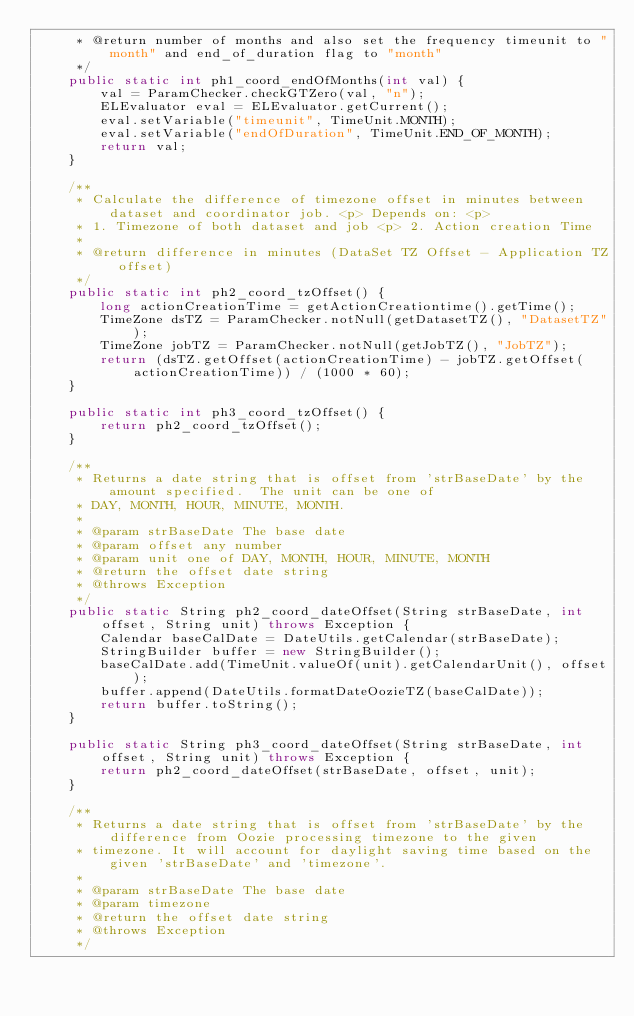<code> <loc_0><loc_0><loc_500><loc_500><_Java_>     * @return number of months and also set the frequency timeunit to "month" and end_of_duration flag to "month"
     */
    public static int ph1_coord_endOfMonths(int val) {
        val = ParamChecker.checkGTZero(val, "n");
        ELEvaluator eval = ELEvaluator.getCurrent();
        eval.setVariable("timeunit", TimeUnit.MONTH);
        eval.setVariable("endOfDuration", TimeUnit.END_OF_MONTH);
        return val;
    }

    /**
     * Calculate the difference of timezone offset in minutes between dataset and coordinator job. <p> Depends on: <p>
     * 1. Timezone of both dataset and job <p> 2. Action creation Time
     *
     * @return difference in minutes (DataSet TZ Offset - Application TZ offset)
     */
    public static int ph2_coord_tzOffset() {
        long actionCreationTime = getActionCreationtime().getTime();
        TimeZone dsTZ = ParamChecker.notNull(getDatasetTZ(), "DatasetTZ");
        TimeZone jobTZ = ParamChecker.notNull(getJobTZ(), "JobTZ");
        return (dsTZ.getOffset(actionCreationTime) - jobTZ.getOffset(actionCreationTime)) / (1000 * 60);
    }

    public static int ph3_coord_tzOffset() {
        return ph2_coord_tzOffset();
    }

    /**
     * Returns a date string that is offset from 'strBaseDate' by the amount specified.  The unit can be one of
     * DAY, MONTH, HOUR, MINUTE, MONTH.
     *
     * @param strBaseDate The base date
     * @param offset any number
     * @param unit one of DAY, MONTH, HOUR, MINUTE, MONTH
     * @return the offset date string
     * @throws Exception
     */
    public static String ph2_coord_dateOffset(String strBaseDate, int offset, String unit) throws Exception {
        Calendar baseCalDate = DateUtils.getCalendar(strBaseDate);
        StringBuilder buffer = new StringBuilder();
        baseCalDate.add(TimeUnit.valueOf(unit).getCalendarUnit(), offset);
        buffer.append(DateUtils.formatDateOozieTZ(baseCalDate));
        return buffer.toString();
    }

    public static String ph3_coord_dateOffset(String strBaseDate, int offset, String unit) throws Exception {
        return ph2_coord_dateOffset(strBaseDate, offset, unit);
    }

    /**
     * Returns a date string that is offset from 'strBaseDate' by the difference from Oozie processing timezone to the given
     * timezone. It will account for daylight saving time based on the given 'strBaseDate' and 'timezone'.
     *
     * @param strBaseDate The base date
     * @param timezone
     * @return the offset date string
     * @throws Exception
     */</code> 